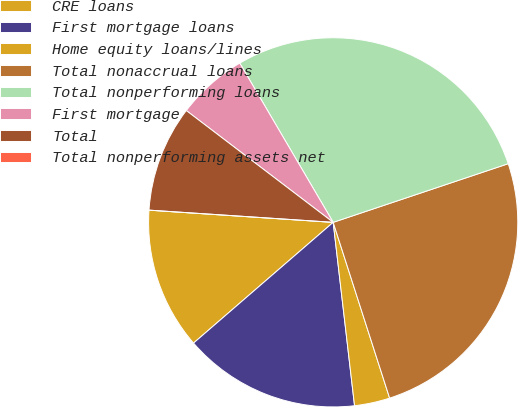Convert chart to OTSL. <chart><loc_0><loc_0><loc_500><loc_500><pie_chart><fcel>CRE loans<fcel>First mortgage loans<fcel>Home equity loans/lines<fcel>Total nonaccrual loans<fcel>Total nonperforming loans<fcel>First mortgage<fcel>Total<fcel>Total nonperforming assets net<nl><fcel>12.4%<fcel>15.5%<fcel>3.1%<fcel>25.2%<fcel>28.3%<fcel>6.2%<fcel>9.3%<fcel>0.0%<nl></chart> 